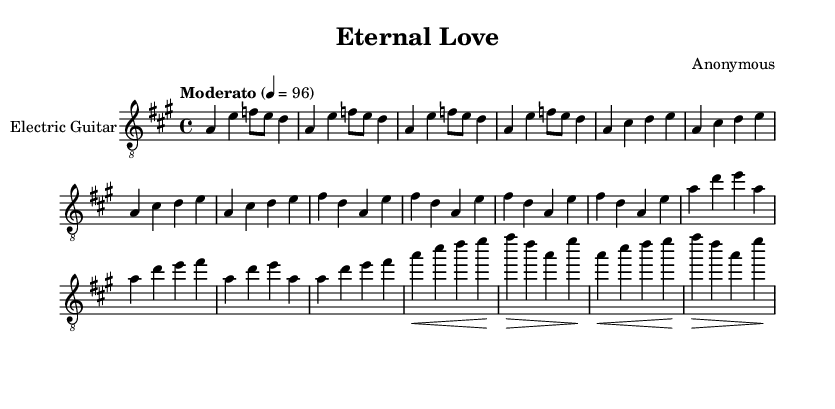What is the key signature of this music? The key signature indicated in the music is A major, which contains three sharps (F#, C#, and G#). This can be confirmed by looking at the key signature at the beginning of the staff.
Answer: A major What is the time signature of this music? The time signature shown in the music is 4/4, which means there are four beats in each measure and the quarter note gets one beat. This is typically indicated at the beginning of the staff.
Answer: 4/4 What is the tempo marking for this piece? The tempo marking listed in the music states "Moderato," indicating a moderate speed, and the metronome mark of 4 = 96 specifies that there are 96 quarter notes per minute. This is found at the top of the score under the tempo indication.
Answer: Moderato How many measures are in the solo section? The solo section is presented over four measures, which can be determined by counting the vertical bar lines that indicate the ends of measures. The solo section is specifically labeled in the music, making it easier to count.
Answer: 4 What is the dynamic marking before the guitar solo? The dynamic marking before the guitar solo indicates a crescendo (indicated by the "<" symbol), meaning to gradually increase the volume. This marking appears right before the solo begins.
Answer: Crescendo Which note is the last note of the chorus section? The last note of the chorus section is an F sharp, which is the final note in measure 8 of the chorus. This note can be identified by examining the pitch shown in the last measure of the chorus.
Answer: F sharp What is the main theme of the piece characterized by the guitar? The main theme is characterized by romantic melodic lines played on the electric guitar, showing a blend of lyrical phrasing and expressive techniques typical of instrumental rock solos. This can be gleaned through the overall structure and feel of the music.
Answer: Romantic 